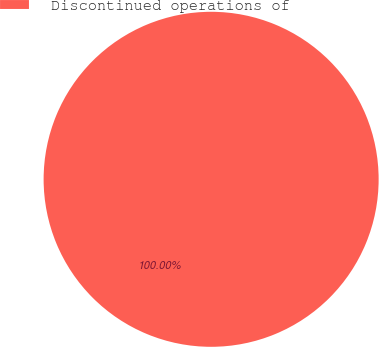Convert chart. <chart><loc_0><loc_0><loc_500><loc_500><pie_chart><fcel>Discontinued operations of<nl><fcel>100.0%<nl></chart> 